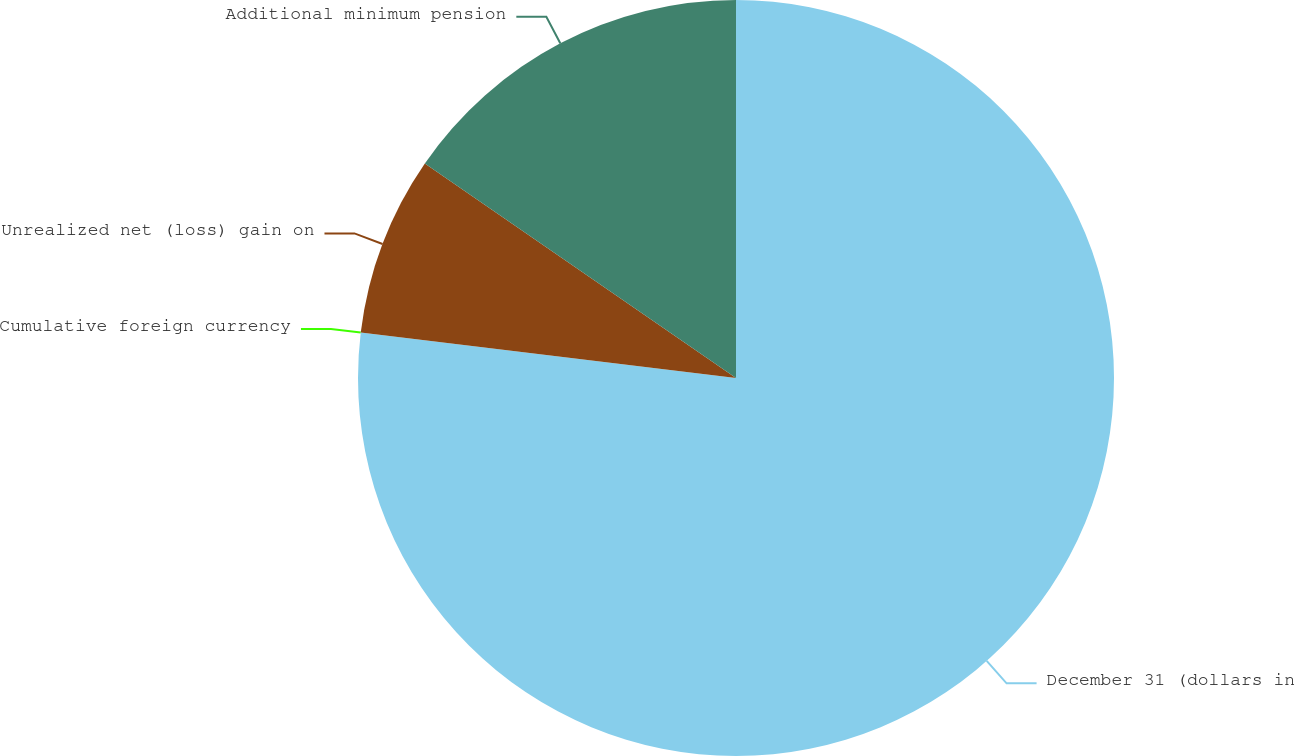Convert chart. <chart><loc_0><loc_0><loc_500><loc_500><pie_chart><fcel>December 31 (dollars in<fcel>Cumulative foreign currency<fcel>Unrealized net (loss) gain on<fcel>Additional minimum pension<nl><fcel>76.92%<fcel>0.0%<fcel>7.69%<fcel>15.39%<nl></chart> 